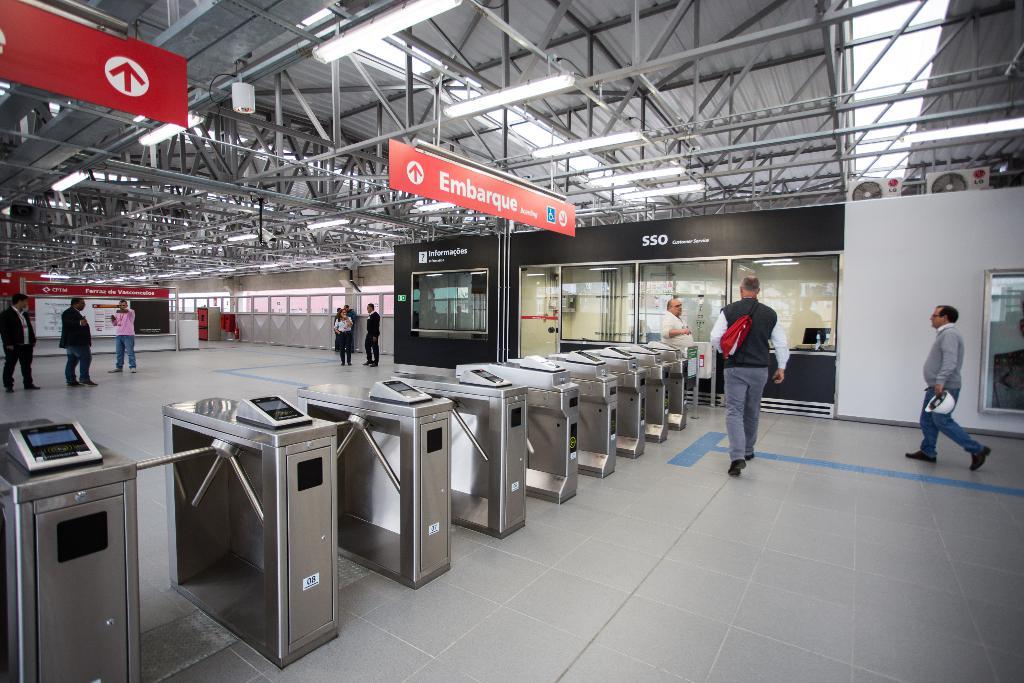What does the sign mention at the top?
Your answer should be very brief. Embarque. What does the black sign say?
Give a very brief answer. Sso. 